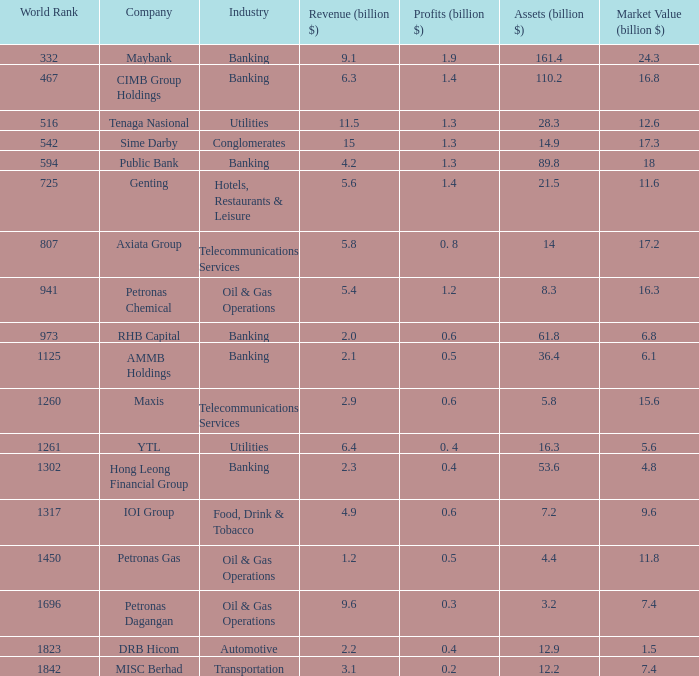Name the industry for revenue being 2.1 Banking. 